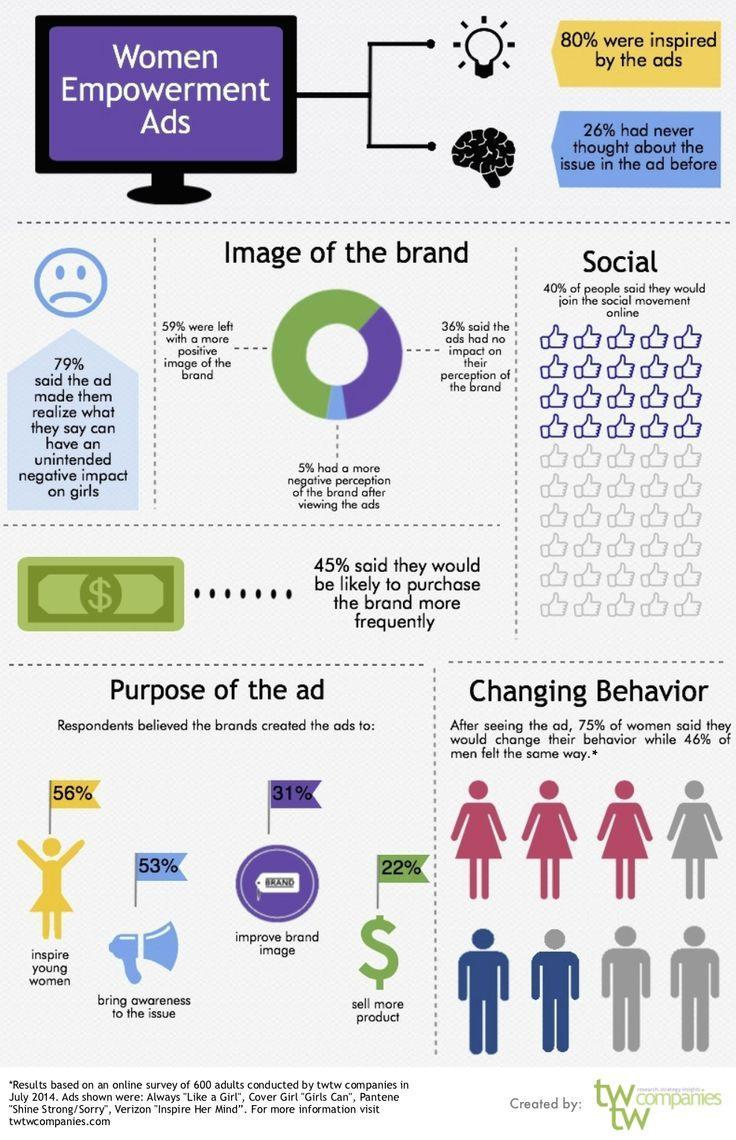What percentage of respondents believed that the purpose of ads is to inspire young women?
Answer the question with a short phrase. 56% What percentage of respondents believed that the purpose of ads is to improve brand image? 31% What percentage of respondents believed that the purpose of ads is to sell more product? 22% What percentage of respondents believed that the purpose of ads is to bring awareness to the issue? 53% 